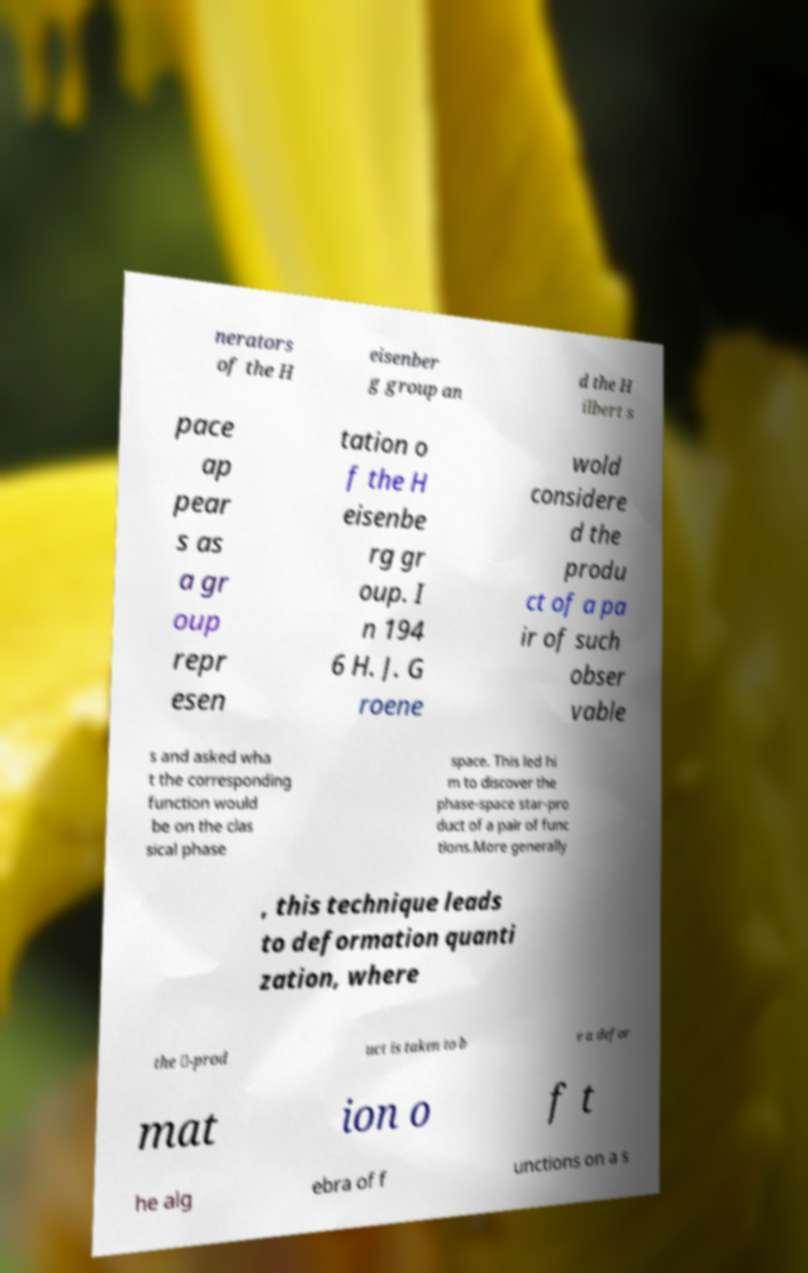I need the written content from this picture converted into text. Can you do that? nerators of the H eisenber g group an d the H ilbert s pace ap pear s as a gr oup repr esen tation o f the H eisenbe rg gr oup. I n 194 6 H. J. G roene wold considere d the produ ct of a pa ir of such obser vable s and asked wha t the corresponding function would be on the clas sical phase space. This led hi m to discover the phase-space star-pro duct of a pair of func tions.More generally , this technique leads to deformation quanti zation, where the ★-prod uct is taken to b e a defor mat ion o f t he alg ebra of f unctions on a s 